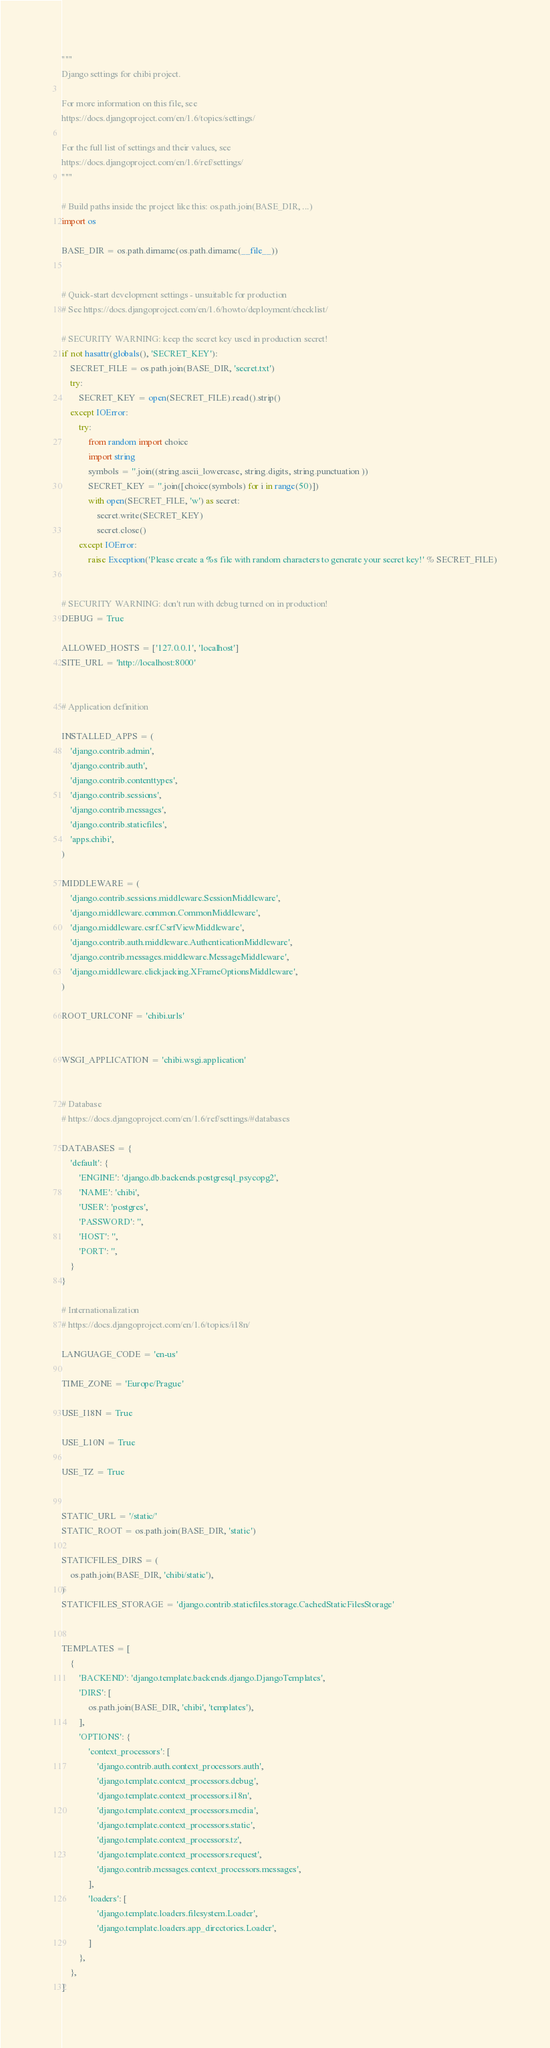<code> <loc_0><loc_0><loc_500><loc_500><_Python_>"""
Django settings for chibi project.

For more information on this file, see
https://docs.djangoproject.com/en/1.6/topics/settings/

For the full list of settings and their values, see
https://docs.djangoproject.com/en/1.6/ref/settings/
"""

# Build paths inside the project like this: os.path.join(BASE_DIR, ...)
import os

BASE_DIR = os.path.dirname(os.path.dirname(__file__))


# Quick-start development settings - unsuitable for production
# See https://docs.djangoproject.com/en/1.6/howto/deployment/checklist/

# SECURITY WARNING: keep the secret key used in production secret!
if not hasattr(globals(), 'SECRET_KEY'):
    SECRET_FILE = os.path.join(BASE_DIR, 'secret.txt')
    try:
        SECRET_KEY = open(SECRET_FILE).read().strip()
    except IOError:
        try:
            from random import choice
            import string
            symbols = ''.join((string.ascii_lowercase, string.digits, string.punctuation ))
            SECRET_KEY = ''.join([choice(symbols) for i in range(50)])
            with open(SECRET_FILE, 'w') as secret:
                secret.write(SECRET_KEY)
                secret.close()
        except IOError:
            raise Exception('Please create a %s file with random characters to generate your secret key!' % SECRET_FILE)


# SECURITY WARNING: don't run with debug turned on in production!
DEBUG = True

ALLOWED_HOSTS = ['127.0.0.1', 'localhost']
SITE_URL = 'http://localhost:8000'


# Application definition

INSTALLED_APPS = (
    'django.contrib.admin',
    'django.contrib.auth',
    'django.contrib.contenttypes',
    'django.contrib.sessions',
    'django.contrib.messages',
    'django.contrib.staticfiles',
    'apps.chibi',
)

MIDDLEWARE = (
    'django.contrib.sessions.middleware.SessionMiddleware',
    'django.middleware.common.CommonMiddleware',
    'django.middleware.csrf.CsrfViewMiddleware',
    'django.contrib.auth.middleware.AuthenticationMiddleware',
    'django.contrib.messages.middleware.MessageMiddleware',
    'django.middleware.clickjacking.XFrameOptionsMiddleware',
)

ROOT_URLCONF = 'chibi.urls'


WSGI_APPLICATION = 'chibi.wsgi.application'


# Database
# https://docs.djangoproject.com/en/1.6/ref/settings/#databases

DATABASES = {
    'default': {
        'ENGINE': 'django.db.backends.postgresql_psycopg2',
        'NAME': 'chibi',
        'USER': 'postgres',
        'PASSWORD': '',
        'HOST': '',
        'PORT': '',
    }
}

# Internationalization
# https://docs.djangoproject.com/en/1.6/topics/i18n/

LANGUAGE_CODE = 'en-us'

TIME_ZONE = 'Europe/Prague'

USE_I18N = True

USE_L10N = True

USE_TZ = True


STATIC_URL = '/static/'
STATIC_ROOT = os.path.join(BASE_DIR, 'static')

STATICFILES_DIRS = (
    os.path.join(BASE_DIR, 'chibi/static'),
)
STATICFILES_STORAGE = 'django.contrib.staticfiles.storage.CachedStaticFilesStorage'


TEMPLATES = [
    {
        'BACKEND': 'django.template.backends.django.DjangoTemplates',
        'DIRS': [
            os.path.join(BASE_DIR, 'chibi', 'templates'),
        ],
        'OPTIONS': {
            'context_processors': [
                'django.contrib.auth.context_processors.auth',
                'django.template.context_processors.debug',
                'django.template.context_processors.i18n',
                'django.template.context_processors.media',
                'django.template.context_processors.static',
                'django.template.context_processors.tz',
                'django.template.context_processors.request',
                'django.contrib.messages.context_processors.messages',
            ],
            'loaders': [
                'django.template.loaders.filesystem.Loader',
                'django.template.loaders.app_directories.Loader',
            ]
        },
    },
]
</code> 